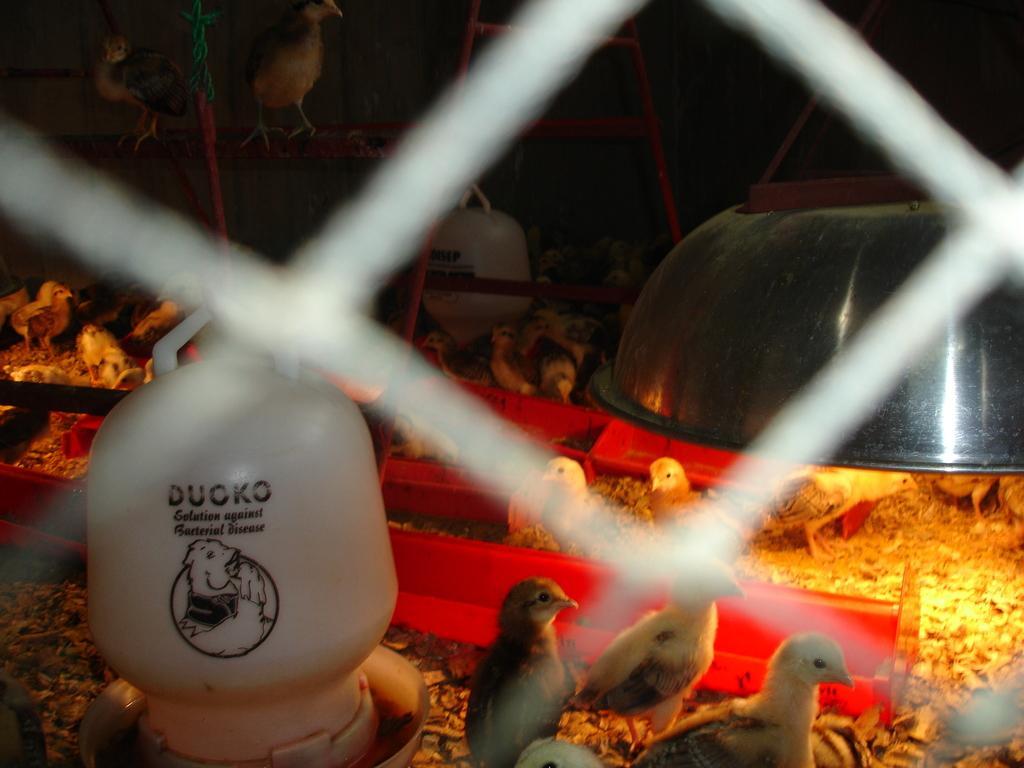In one or two sentences, can you explain what this image depicts? In the image in the center,we can see one jar,bowl,light,poles,birds and few other objects. 